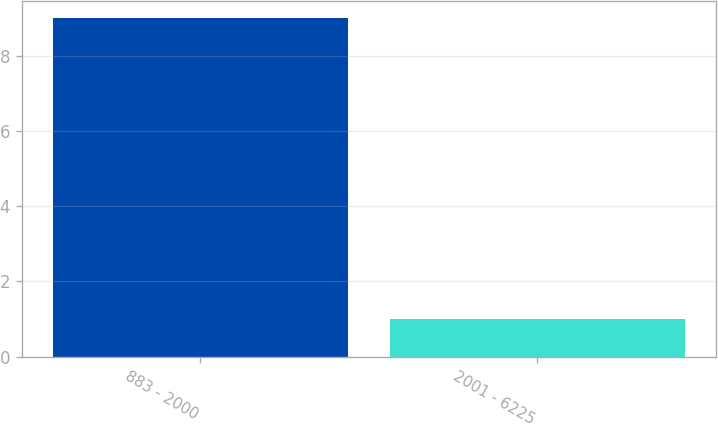<chart> <loc_0><loc_0><loc_500><loc_500><bar_chart><fcel>883 - 2000<fcel>2001 - 6225<nl><fcel>9<fcel>1<nl></chart> 